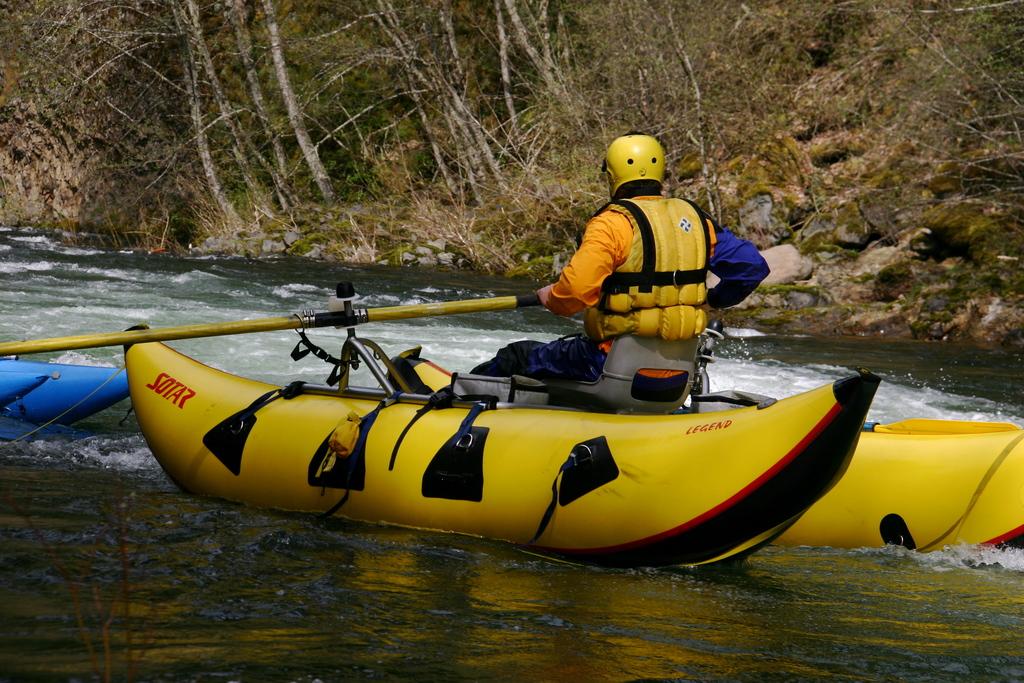What brand is the boat?
Make the answer very short. Sotar. What is written in red letters towards the rear of the boat?
Offer a very short reply. Sotar. 